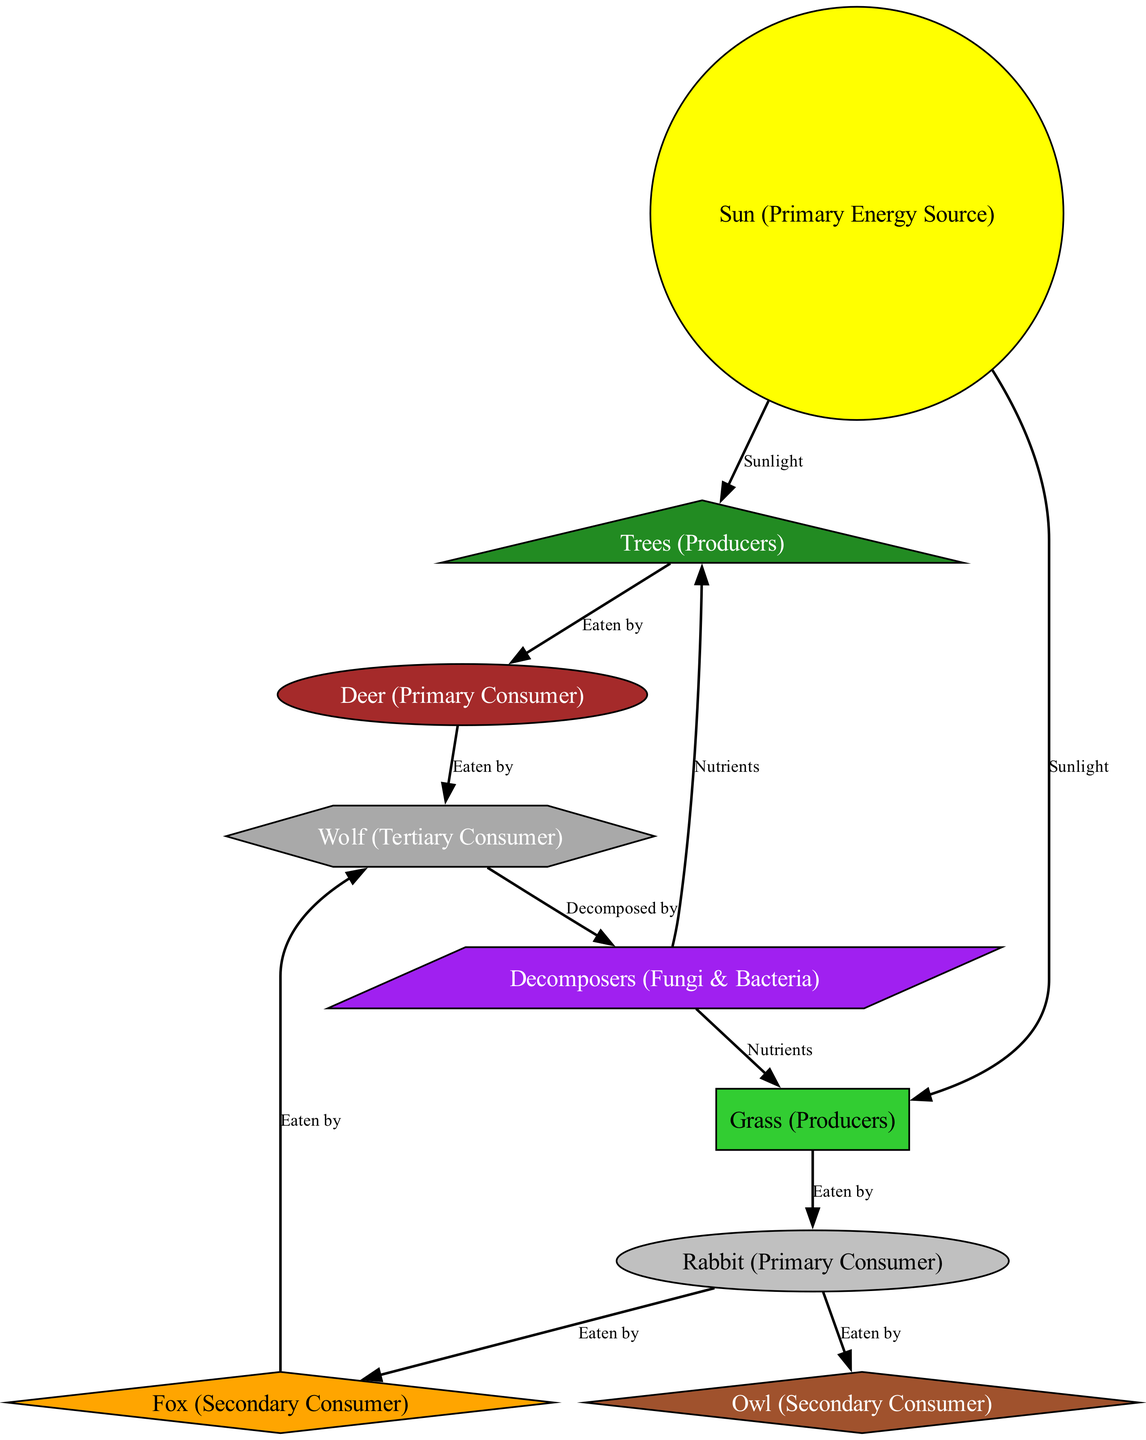What is the primary energy source in the forest ecosystem? The diagram shows a node labeled "Sun (Primary Energy Source)" which indicates that sunlight is the primary energy source for the forest ecosystem.
Answer: Sun How many primary consumers are represented in the diagram? The diagram identifies two primary consumers, which are "Deer" and "Rabbit", therefore the total is counted as 2.
Answer: 2 Which producer is eaten by the rabbit? The diagram clearly indicates that the "Grass (Producers)" is eaten by the "Rabbit (Primary Consumer)" through their connecting edge labeled "Eaten by".
Answer: Grass What do decomposers provide to trees? According to the diagram, there is an edge from "Decomposers" to "Trees" labeled "Nutrients", highlighting that decomposers provide nutrients to the trees.
Answer: Nutrients Which animal is a tertiary consumer in this ecosystem? The diagram specifies "Wolf (Tertiary Consumer)" as the only node that functions as a tertiary consumer based on its relationships with other nodes.
Answer: Wolf Which two forms of producers receive sunlight? The "Trees" and "Grass" nodes in the diagram both have edges from the "Sun" node labeled "Sunlight", indicating they receive sunlight as producers.
Answer: Trees and Grass Which animal in the diagram can be consumed by both the fox and the owl? Analysis of the diagram reveals that the "Rabbit" is linked to both the "Fox" and "Owl" via edges labeled "Eaten by".
Answer: Rabbit How do decomposers contribute to the forest ecosystem? The diagram shows arrows connecting decomposers to both "Grass" and "Trees" with the label "Nutrients", indicating that they recycle nutrients essential for plant growth.
Answer: Nutrients What is the relationship between deer and wolves? The diagram illustrates that "Deer" is eaten by "Wolf", denoting a predator-prey relationship through the edge labeled "Eaten by".
Answer: Eaten by 